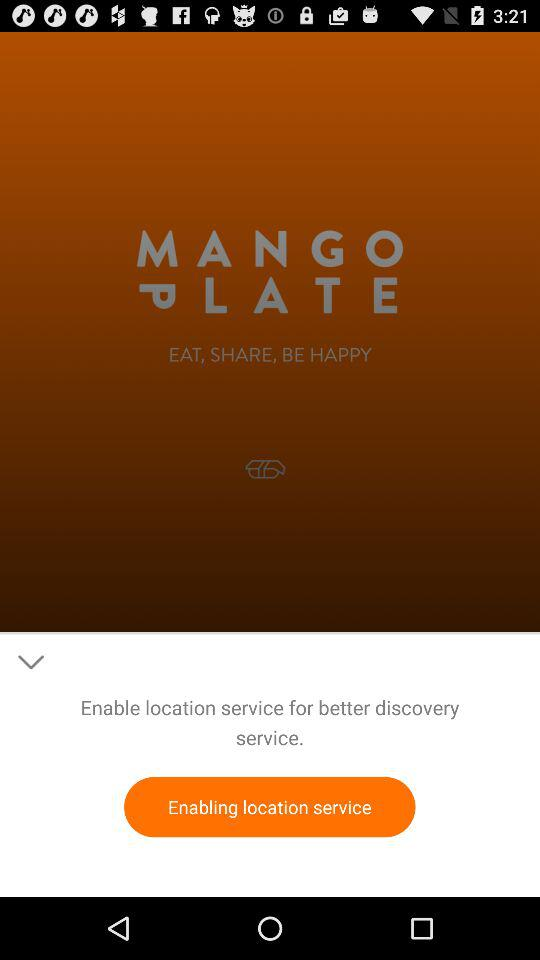Is location service enable?
When the provided information is insufficient, respond with <no answer>. <no answer> 